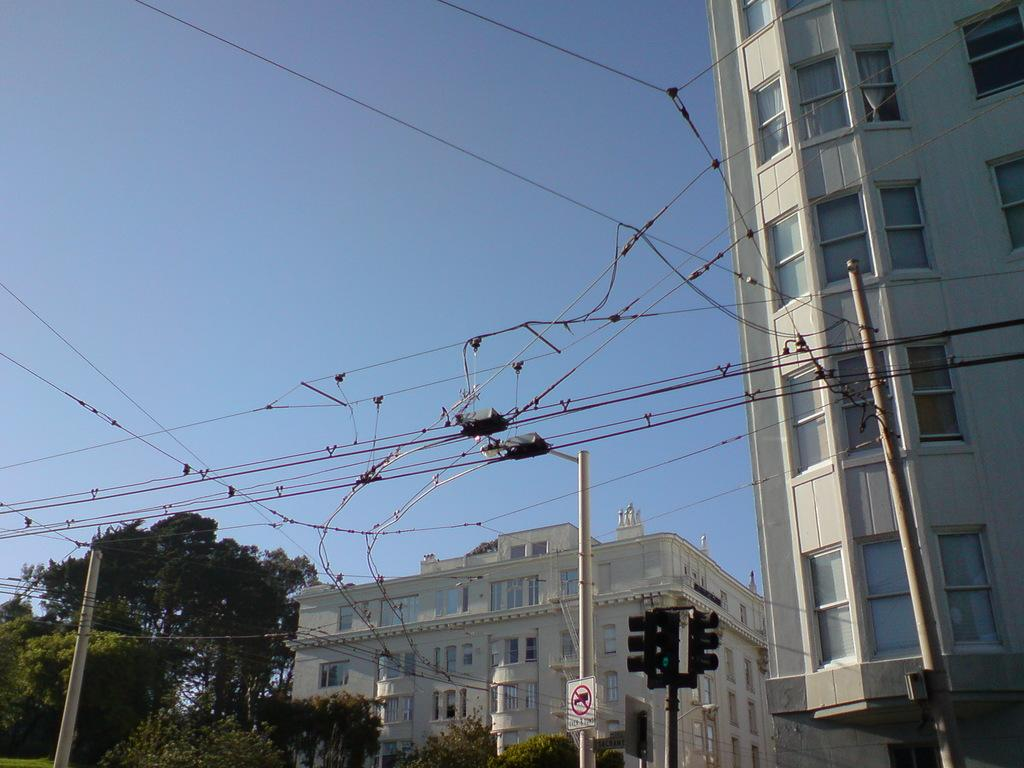What type of structures can be seen in the image? There are buildings with windows in the image. What type of infrastructure is present in the image? Current wires and poles are visible in the image. What type of vegetation is present in the image? Trees are present in the image. What type of traffic control device is in the image? Traffic lights are in the image. What is visible in the background of the image? The sky is visible in the background of the image. Can you see any wounds on the trees in the image? There is no mention of wounds on the trees in the image, and trees do not have the ability to experience wounds like living beings. What type of hair is visible on the traffic lights in the image? There is no hair present on the traffic lights in the image, as they are inanimate objects made of metal and plastic. 